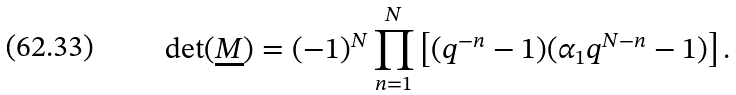<formula> <loc_0><loc_0><loc_500><loc_500>\det ( \underline { M } ) = ( - 1 ) ^ { N } \prod _ { n = 1 } ^ { N } \left [ ( q ^ { - n } - 1 ) ( \alpha _ { 1 } q ^ { N - n } - 1 ) \right ] .</formula> 